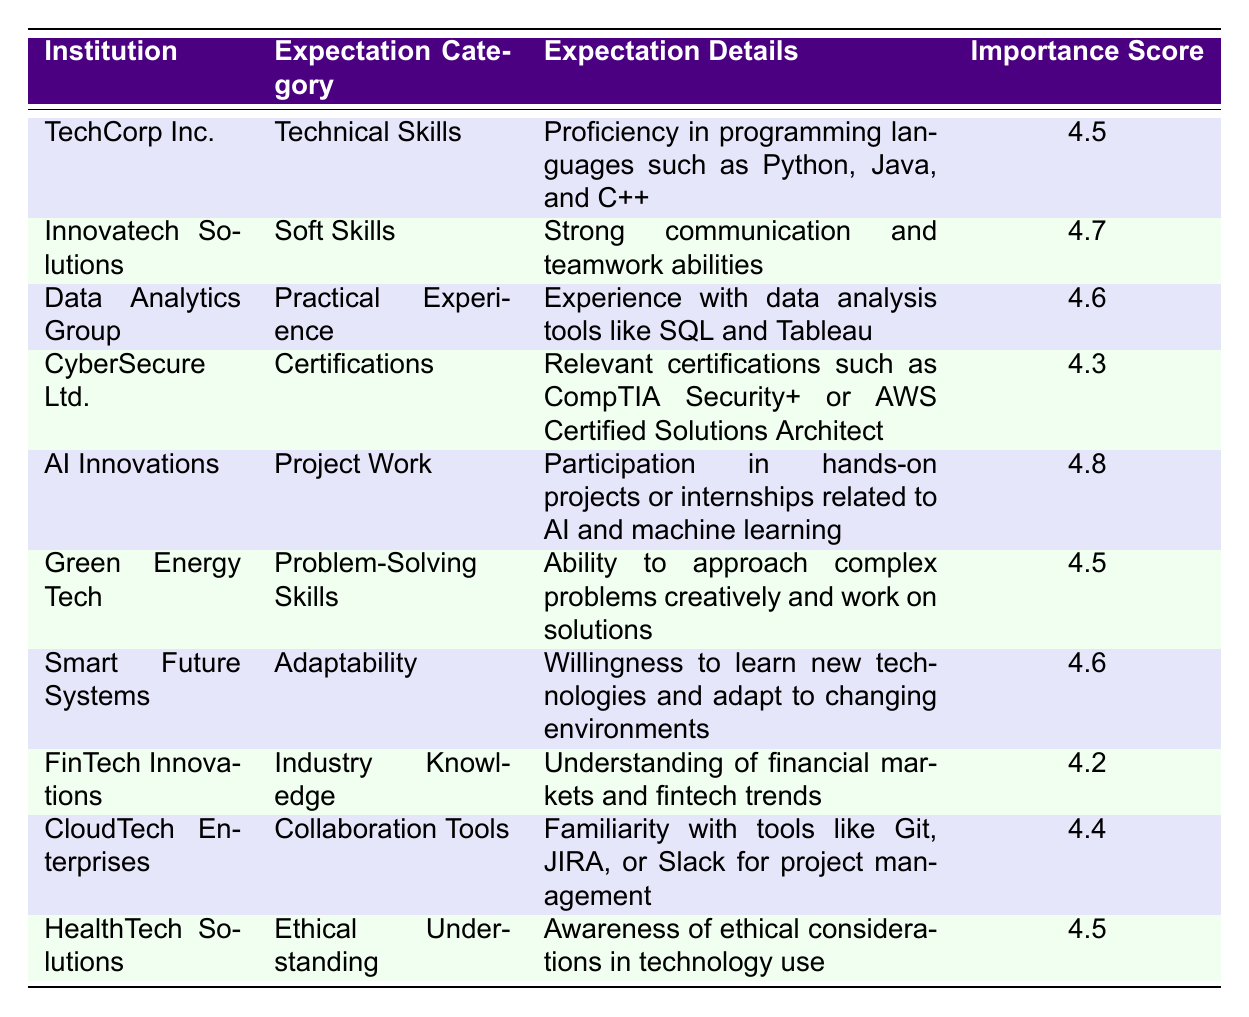What institution has the highest importance score for employer expectations? By examining the importance scores in the table, I identify the highest value of 4.8 associated with AI Innovations under the 'Project Work' category.
Answer: AI Innovations What are the expectation details for Soft Skills according to Innovatech Solutions? I reference the row for Innovatech Solutions under the 'Soft Skills' category, where it is specified that the expectation details include 'Strong communication and teamwork abilities.'
Answer: Strong communication and teamwork abilities Is the importance score for Practical Experience higher than that for Certifications? I compare the importance scores for 'Practical Experience' (4.6) and 'Certifications' (4.3). Since 4.6 is greater than 4.3, the statement is true.
Answer: Yes What is the average importance score across all expectation categories? First, I sum all the importance scores: 4.5 + 4.7 + 4.6 + 4.3 + 4.8 + 4.5 + 4.6 + 4.2 + 4.4 + 4.5 = 46.7. Then, I divide this sum by the number of categories (10), which gives an average of 46.7 / 10 = 4.67.
Answer: 4.67 Are there any institutions that require understanding of ethical considerations in technology use? Referring to the table, HealthTech Solutions under the category 'Ethical Understanding' shows an expectation for awareness of ethical considerations. Thus, the answer is yes.
Answer: Yes Which institution expects industry knowledge related to financial markets? I look for the institution associated with 'Industry Knowledge,' which is FinTech Innovations, and the expectation details indicate a requirement for understanding financial markets and fintech trends.
Answer: FinTech Innovations What is the difference between the importance score of Project Work and Industry Knowledge? The importance score for 'Project Work' is 4.8 and for 'Industry Knowledge' it is 4.2. The difference is calculated as 4.8 - 4.2 = 0.6.
Answer: 0.6 Which categories have an importance score at or above 4.5? Reviewing the categories, the following have scores of 4.5 or higher: Technical Skills, Soft Skills, Practical Experience, Project Work, Problem-Solving Skills, Adaptability, Ethical Understanding. Counting these, there are 7 categories.
Answer: 7 Which expectation category related to technical fields has the lowest importance score listed? I check the importance scores and find that the 'Industry Knowledge' category has the lowest score of 4.2 compared to others.
Answer: Industry Knowledge 